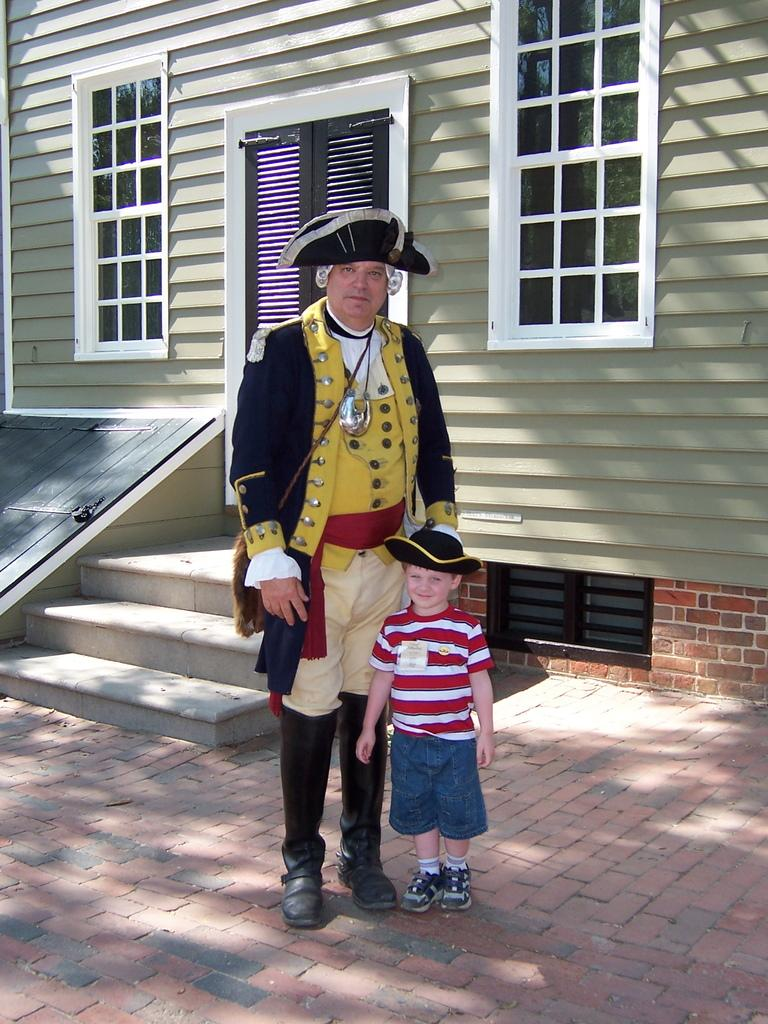Who are the two people in the image? There is a man and a small boy in the image. Where are the man and the small boy located in the image? They are standing in the foreground area of the image. What can be seen in the background of the image? There are stairs and a house in the background of the image. What type of kettle is being used by the nation in the image? There is no mention of a nation or a kettle in the image; it features a man and a small boy standing in front of a house with stairs in the background. 